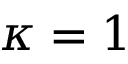<formula> <loc_0><loc_0><loc_500><loc_500>\kappa = 1</formula> 